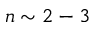<formula> <loc_0><loc_0><loc_500><loc_500>n \sim 2 - 3</formula> 